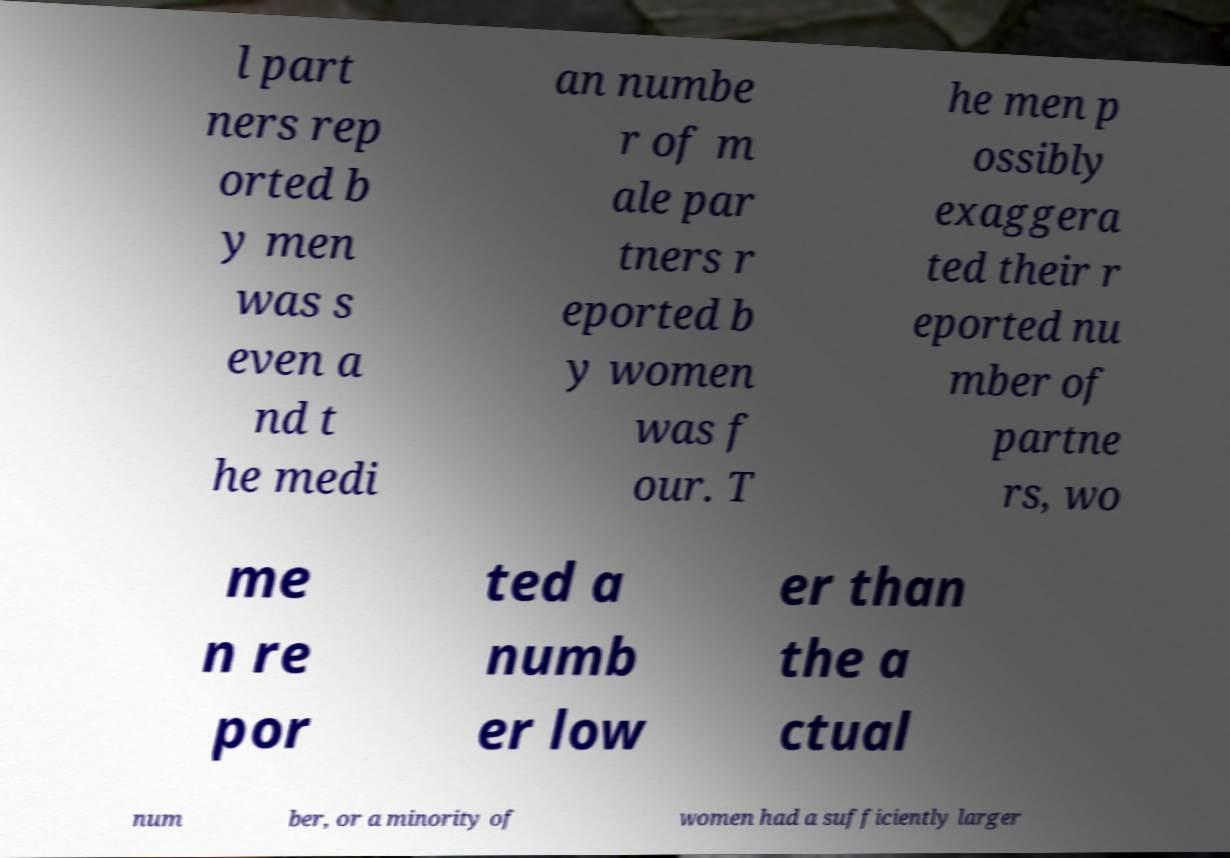Can you accurately transcribe the text from the provided image for me? l part ners rep orted b y men was s even a nd t he medi an numbe r of m ale par tners r eported b y women was f our. T he men p ossibly exaggera ted their r eported nu mber of partne rs, wo me n re por ted a numb er low er than the a ctual num ber, or a minority of women had a sufficiently larger 